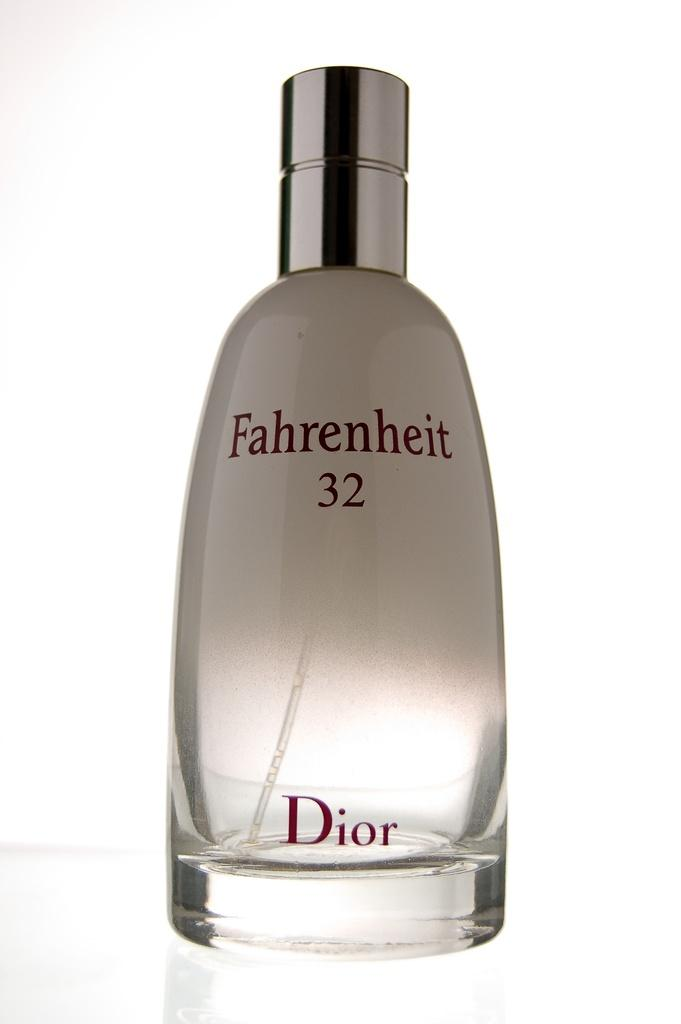<image>
Present a compact description of the photo's key features. A clear bottle of Fahrenheit 32 perfume by Dior. 